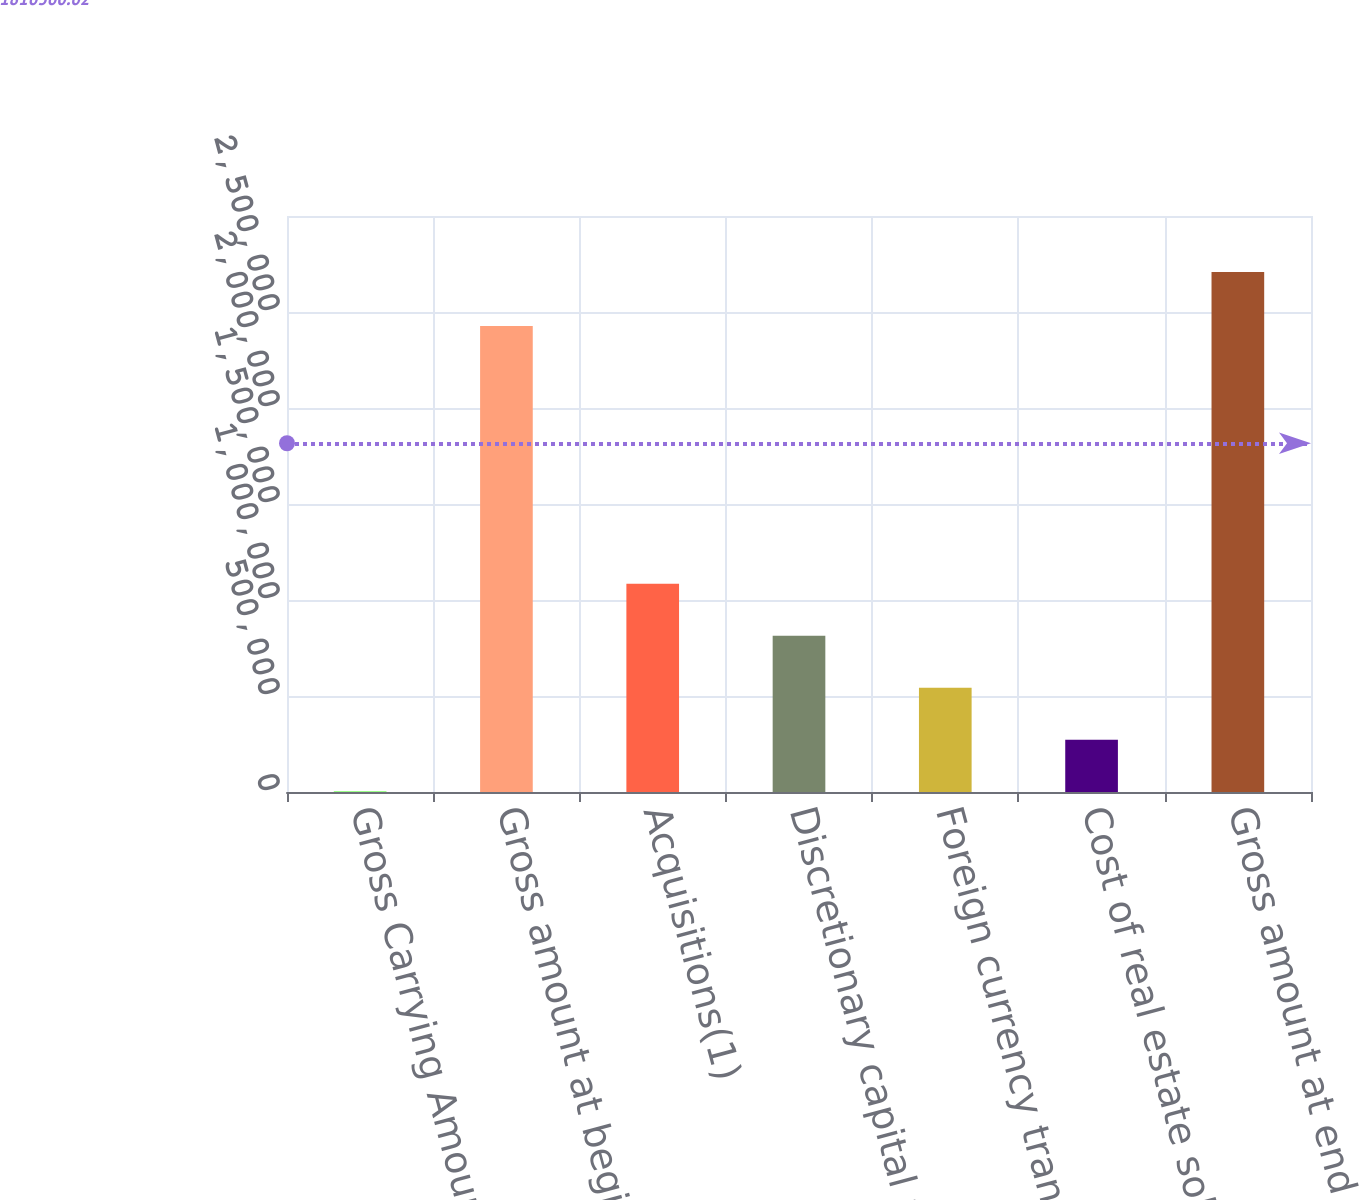Convert chart to OTSL. <chart><loc_0><loc_0><loc_500><loc_500><bar_chart><fcel>Gross Carrying Amount of Real<fcel>Gross amount at beginning of<fcel>Acquisitions(1)<fcel>Discretionary capital projects<fcel>Foreign currency translation<fcel>Cost of real estate sold or<fcel>Gross amount at end of period<nl><fcel>2017<fcel>2.42754e+06<fcel>1.08438e+06<fcel>813789<fcel>543199<fcel>272608<fcel>2.70792e+06<nl></chart> 